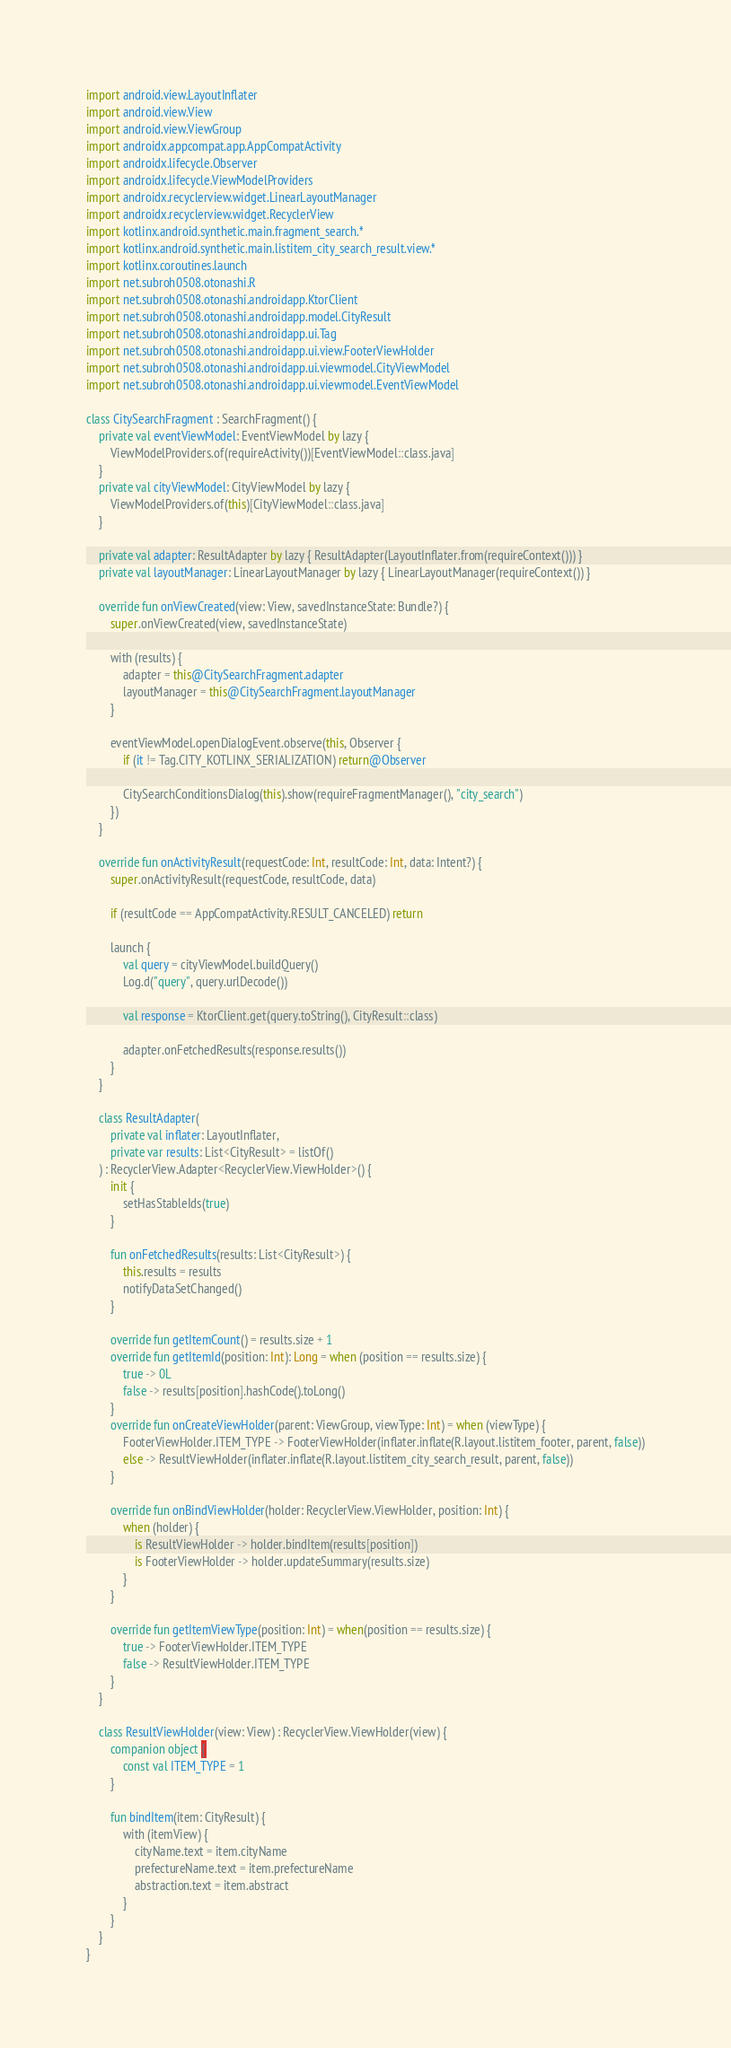<code> <loc_0><loc_0><loc_500><loc_500><_Kotlin_>import android.view.LayoutInflater
import android.view.View
import android.view.ViewGroup
import androidx.appcompat.app.AppCompatActivity
import androidx.lifecycle.Observer
import androidx.lifecycle.ViewModelProviders
import androidx.recyclerview.widget.LinearLayoutManager
import androidx.recyclerview.widget.RecyclerView
import kotlinx.android.synthetic.main.fragment_search.*
import kotlinx.android.synthetic.main.listitem_city_search_result.view.*
import kotlinx.coroutines.launch
import net.subroh0508.otonashi.R
import net.subroh0508.otonashi.androidapp.KtorClient
import net.subroh0508.otonashi.androidapp.model.CityResult
import net.subroh0508.otonashi.androidapp.ui.Tag
import net.subroh0508.otonashi.androidapp.ui.view.FooterViewHolder
import net.subroh0508.otonashi.androidapp.ui.viewmodel.CityViewModel
import net.subroh0508.otonashi.androidapp.ui.viewmodel.EventViewModel

class CitySearchFragment : SearchFragment() {
    private val eventViewModel: EventViewModel by lazy {
        ViewModelProviders.of(requireActivity())[EventViewModel::class.java]
    }
    private val cityViewModel: CityViewModel by lazy {
        ViewModelProviders.of(this)[CityViewModel::class.java]
    }

    private val adapter: ResultAdapter by lazy { ResultAdapter(LayoutInflater.from(requireContext())) }
    private val layoutManager: LinearLayoutManager by lazy { LinearLayoutManager(requireContext()) }

    override fun onViewCreated(view: View, savedInstanceState: Bundle?) {
        super.onViewCreated(view, savedInstanceState)

        with (results) {
            adapter = this@CitySearchFragment.adapter
            layoutManager = this@CitySearchFragment.layoutManager
        }

        eventViewModel.openDialogEvent.observe(this, Observer {
            if (it != Tag.CITY_KOTLINX_SERIALIZATION) return@Observer

            CitySearchConditionsDialog(this).show(requireFragmentManager(), "city_search")
        })
    }

    override fun onActivityResult(requestCode: Int, resultCode: Int, data: Intent?) {
        super.onActivityResult(requestCode, resultCode, data)

        if (resultCode == AppCompatActivity.RESULT_CANCELED) return

        launch {
            val query = cityViewModel.buildQuery()
            Log.d("query", query.urlDecode())

            val response = KtorClient.get(query.toString(), CityResult::class)

            adapter.onFetchedResults(response.results())
        }
    }

    class ResultAdapter(
        private val inflater: LayoutInflater,
        private var results: List<CityResult> = listOf()
    ) : RecyclerView.Adapter<RecyclerView.ViewHolder>() {
        init {
            setHasStableIds(true)
        }

        fun onFetchedResults(results: List<CityResult>) {
            this.results = results
            notifyDataSetChanged()
        }

        override fun getItemCount() = results.size + 1
        override fun getItemId(position: Int): Long = when (position == results.size) {
            true -> 0L
            false -> results[position].hashCode().toLong()
        }
        override fun onCreateViewHolder(parent: ViewGroup, viewType: Int) = when (viewType) {
            FooterViewHolder.ITEM_TYPE -> FooterViewHolder(inflater.inflate(R.layout.listitem_footer, parent, false))
            else -> ResultViewHolder(inflater.inflate(R.layout.listitem_city_search_result, parent, false))
        }

        override fun onBindViewHolder(holder: RecyclerView.ViewHolder, position: Int) {
            when (holder) {
                is ResultViewHolder -> holder.bindItem(results[position])
                is FooterViewHolder -> holder.updateSummary(results.size)
            }
        }

        override fun getItemViewType(position: Int) = when(position == results.size) {
            true -> FooterViewHolder.ITEM_TYPE
            false -> ResultViewHolder.ITEM_TYPE
        }
    }

    class ResultViewHolder(view: View) : RecyclerView.ViewHolder(view) {
        companion object {
            const val ITEM_TYPE = 1
        }

        fun bindItem(item: CityResult) {
            with (itemView) {
                cityName.text = item.cityName
                prefectureName.text = item.prefectureName
                abstraction.text = item.abstract
            }
        }
    }
}</code> 